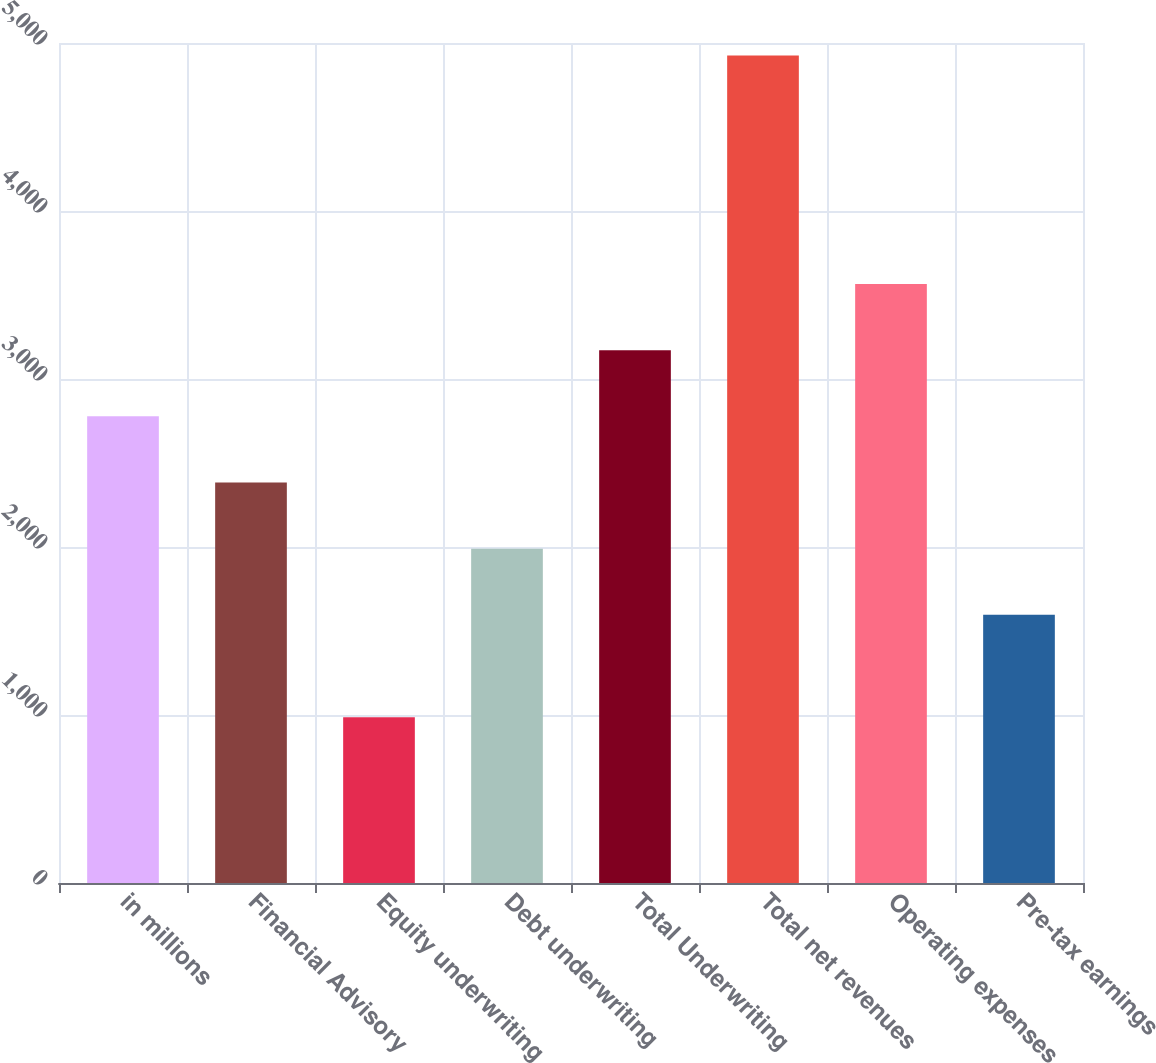Convert chart to OTSL. <chart><loc_0><loc_0><loc_500><loc_500><bar_chart><fcel>in millions<fcel>Financial Advisory<fcel>Equity underwriting<fcel>Debt underwriting<fcel>Total Underwriting<fcel>Total net revenues<fcel>Operating expenses<fcel>Pre-tax earnings<nl><fcel>2777.7<fcel>2383.8<fcel>987<fcel>1989.9<fcel>3171.6<fcel>4926<fcel>3565.5<fcel>1596<nl></chart> 